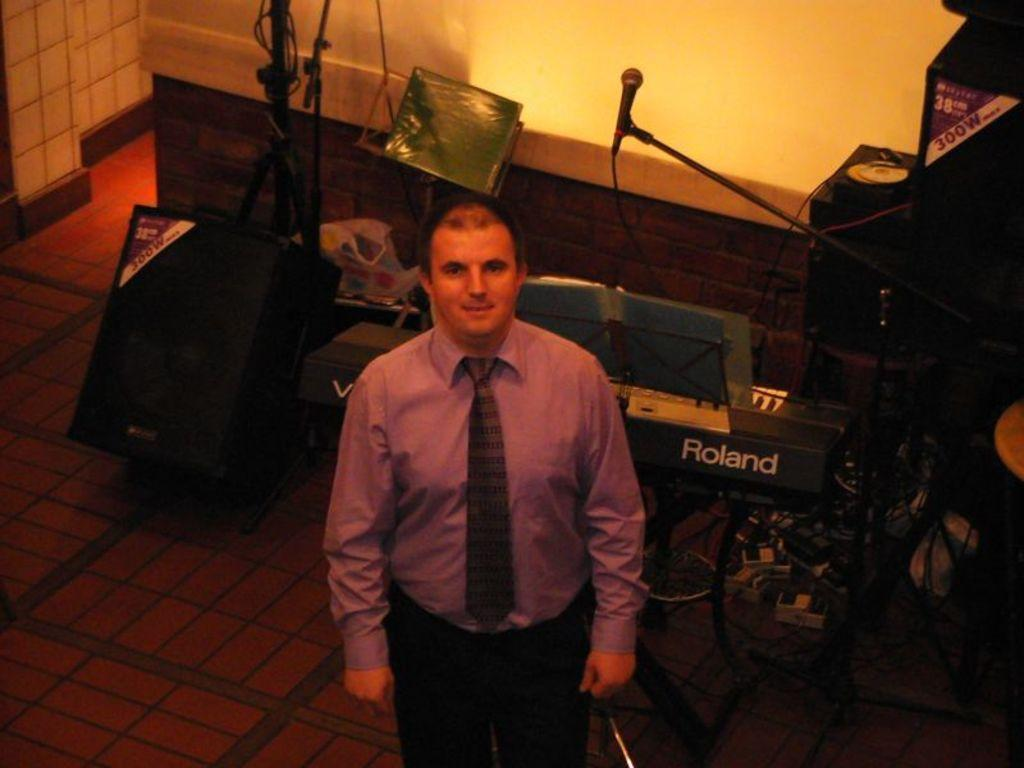What is the main subject in the foreground of the image? There is a man standing in the foreground of the image. What objects can be seen in the background of the image? Speaker boxes, a microphone, a keyboard, a book holder, and a book are visible in the background of the image. What type of surface is the book holder placed on? The book holder is placed on a wall in the background of the image. What is the floor like in the image? The floor is visible in the image. How many friends are sitting on the floor in the image? There are no friends sitting on the floor in the image. What type of baseball equipment can be seen in the image? There is no baseball equipment present in the image. 